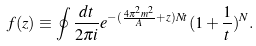Convert formula to latex. <formula><loc_0><loc_0><loc_500><loc_500>f ( z ) \equiv \oint \frac { d t } { 2 \pi i } e ^ { - ( \frac { 4 \pi ^ { 2 } m ^ { 2 } } { A } + z ) N t } ( 1 + \frac { 1 } { t } ) ^ { N } .</formula> 